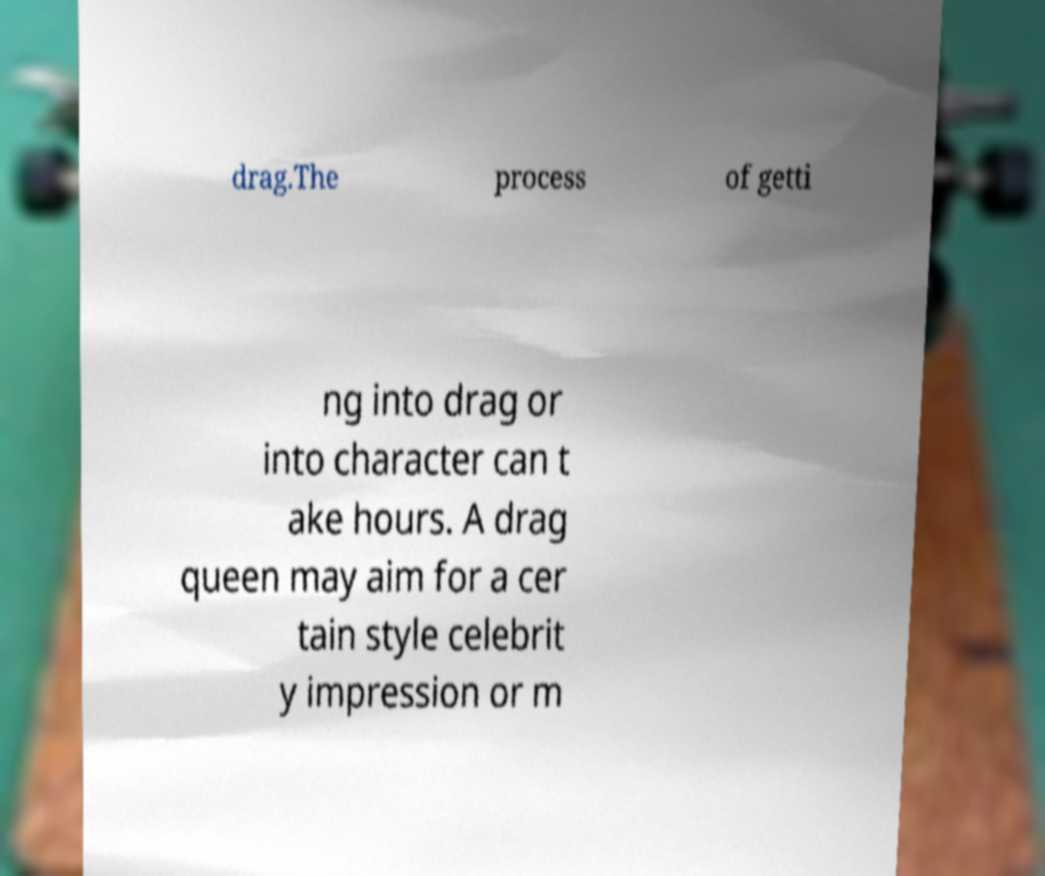Could you assist in decoding the text presented in this image and type it out clearly? drag.The process of getti ng into drag or into character can t ake hours. A drag queen may aim for a cer tain style celebrit y impression or m 